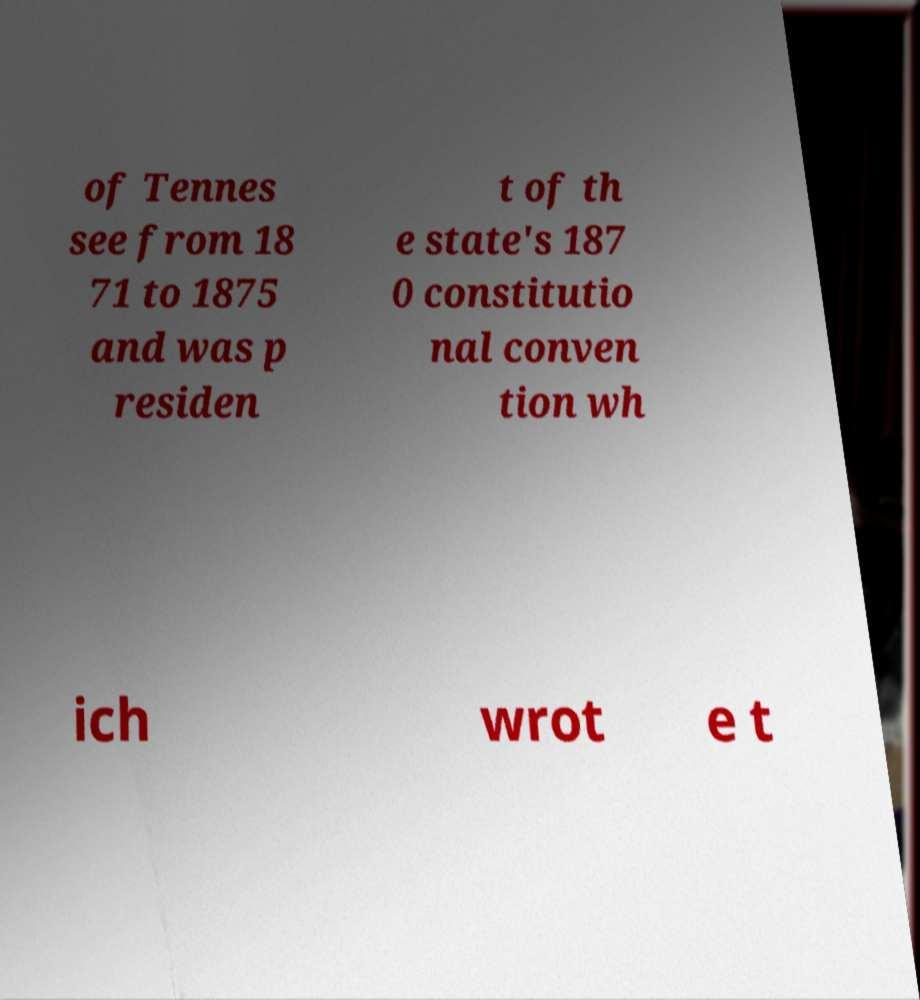Can you read and provide the text displayed in the image?This photo seems to have some interesting text. Can you extract and type it out for me? of Tennes see from 18 71 to 1875 and was p residen t of th e state's 187 0 constitutio nal conven tion wh ich wrot e t 